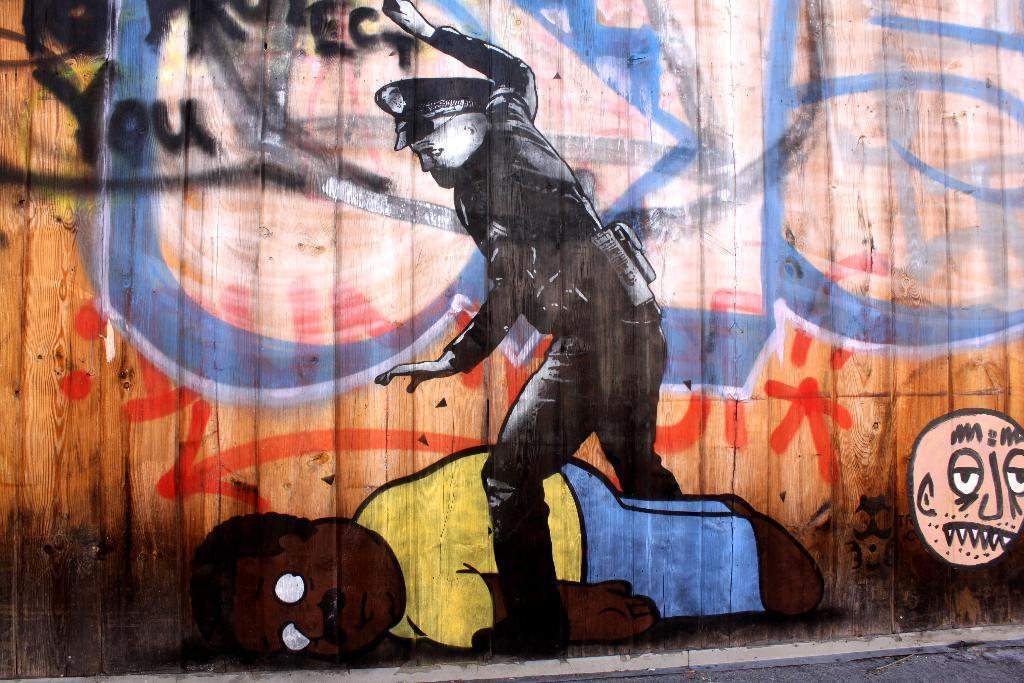What is depicted on the wall in the image? There is graffiti on a wall in the image. How many dogs are playing with a pipe in the image? There are no dogs or pipes present in the image; it only features graffiti on a wall. What type of disease can be seen spreading through the graffiti in the image? There is no disease depicted in the image; it only features graffiti on a wall. 